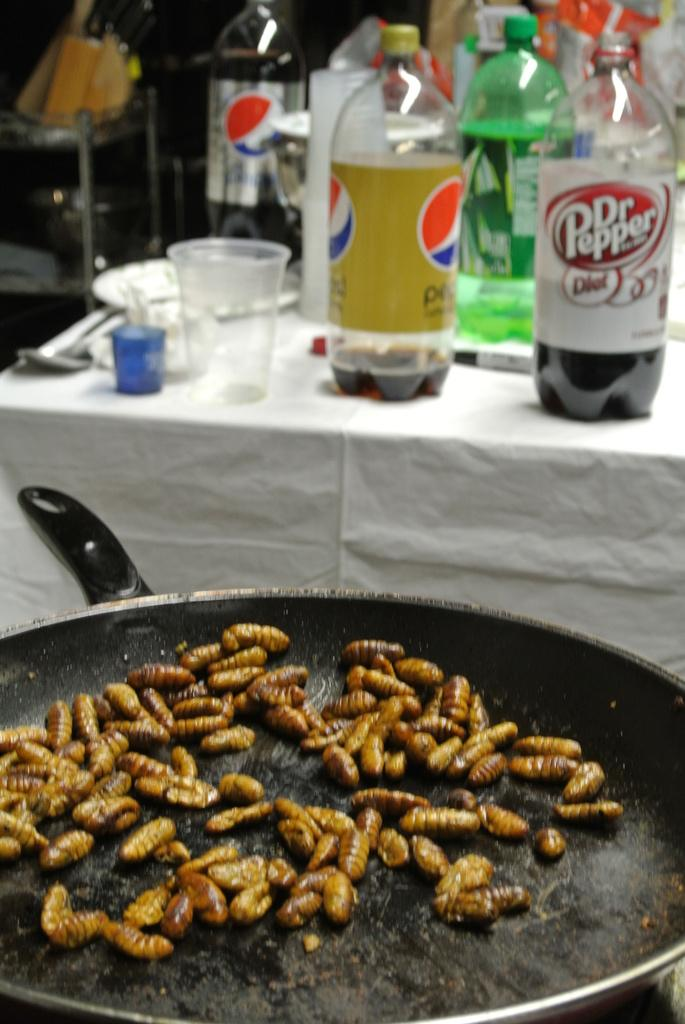<image>
Write a terse but informative summary of the picture. Bugs are cooking in a frying pan, and many bottles of soda, including Dr. Pepper, are on the table behind. 